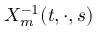<formula> <loc_0><loc_0><loc_500><loc_500>X _ { m } ^ { - 1 } ( t , \cdot , s )</formula> 